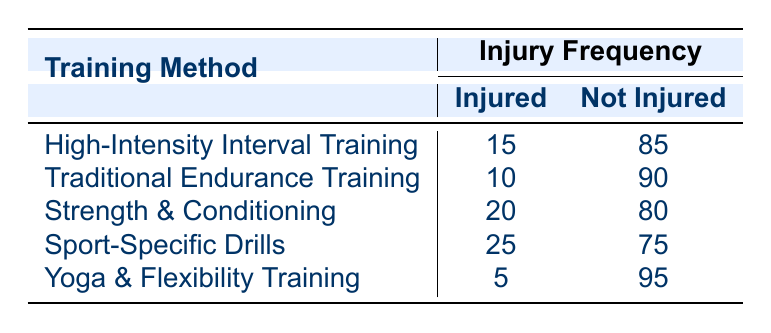What is the injury frequency for players training with Sport-Specific Drills? According to the table, for Sport-Specific Drills, players reported 25 injuries.
Answer: 25 How many players were not injured when using Yoga & Flexibility Training? The table shows that 95 players were not injured when using Yoga & Flexibility Training.
Answer: 95 Which training method has the highest injury frequency? The highest number of injuries is 25 for Sport-Specific Drills, as shown in the "Injured" column.
Answer: Sport-Specific Drills What is the total number of injuries reported across all training methods? To calculate the total number of injuries, add the values in the "Injured" column: 15 + 10 + 20 + 25 + 5 = 75.
Answer: 75 Is it true that players training with Yoga & Flexibility Training have the lowest injury frequency? Yes, the table indicates that Yoga & Flexibility Training has the lowest injury count, which is 5.
Answer: Yes What is the difference in injury frequency between Strength & Conditioning and Traditional Endurance Training? The injuries for Strength & Conditioning are 20, while Traditional Endurance Training has 10 injuries. The difference is 20 - 10 = 10.
Answer: 10 If a player trains using High-Intensity Interval Training, what is the probability of them getting injured? To find the probability, divide the number of injured players (15) by the total number of players (15 injured + 85 not injured = 100). Therefore, the probability is 15/100 = 0.15 or 15%.
Answer: 0.15 What percentage of players are not injured in Sport-Specific Drills? The table shows that 75 players were not injured. To find the percentage, use the formula: (75/100) * 100% = 75%.
Answer: 75% Which training method has a higher ratio of injuries to total players, Traditional Endurance Training or Yoga & Flexibility Training? Traditional Endurance Training has 10 injuries out of 100, yielding a ratio of 10/100 = 0.1 (10%). Yoga & Flexibility Training has 5 injuries, yielding a ratio of 5/100 = 0.05 (5%). Traditional Endurance Training has a higher injury ratio.
Answer: Traditional Endurance Training 